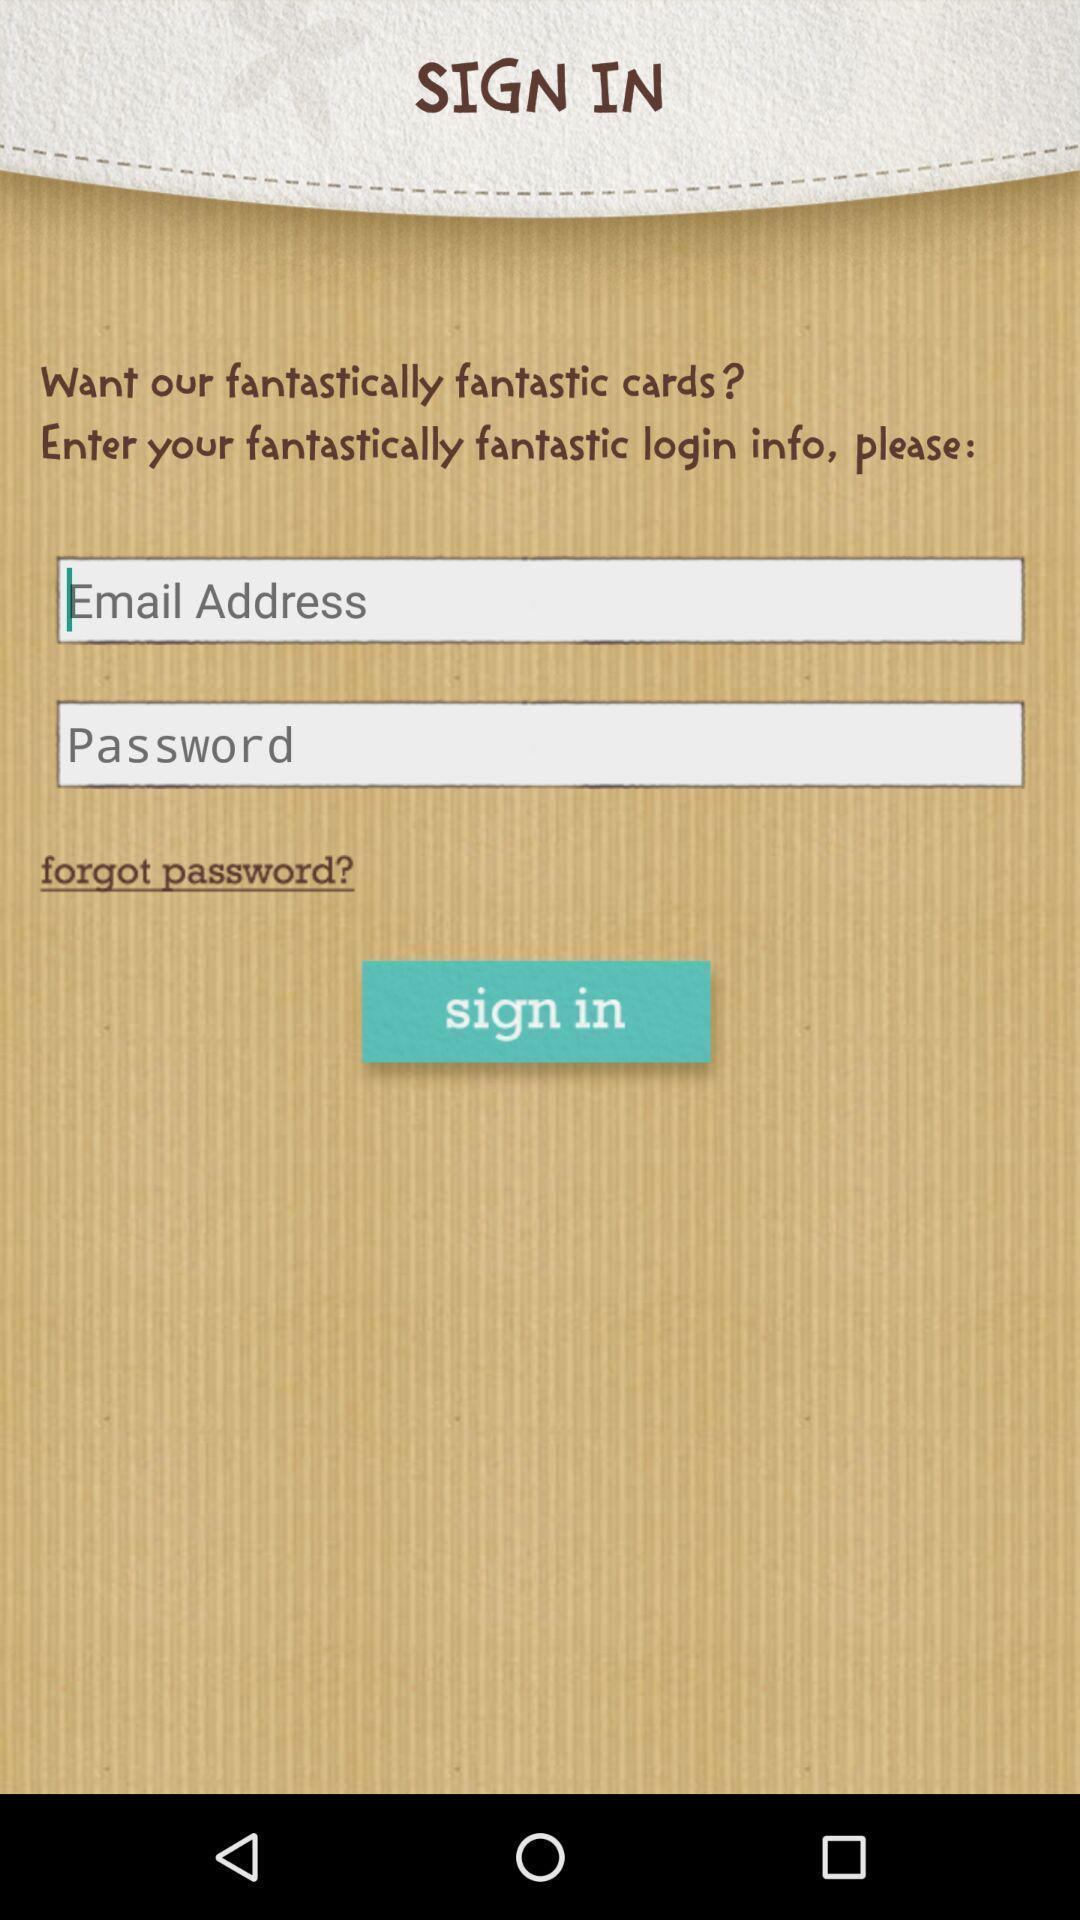What is the overall content of this screenshot? Sign up page. 